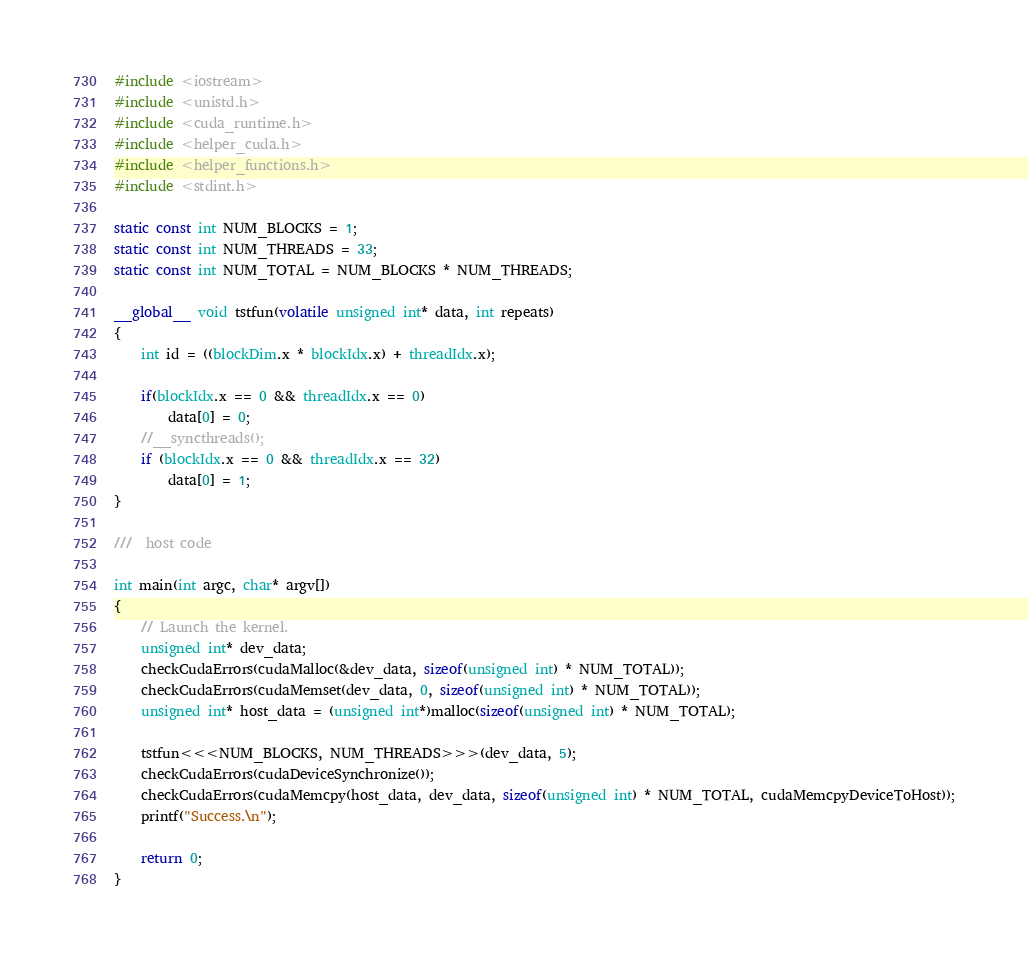<code> <loc_0><loc_0><loc_500><loc_500><_Cuda_>#include <iostream>
#include <unistd.h>
#include <cuda_runtime.h>
#include <helper_cuda.h>
#include <helper_functions.h>
#include <stdint.h>

static const int NUM_BLOCKS = 1;
static const int NUM_THREADS = 33;
static const int NUM_TOTAL = NUM_BLOCKS * NUM_THREADS;

__global__ void tstfun(volatile unsigned int* data, int repeats) 
{
    int id = ((blockDim.x * blockIdx.x) + threadIdx.x);

    if(blockIdx.x == 0 && threadIdx.x == 0)
        data[0] = 0;
    //__syncthreads();
    if (blockIdx.x == 0 && threadIdx.x == 32)
        data[0] = 1;
}

///  host code
    
int main(int argc, char* argv[]) 
{
    // Launch the kernel.
    unsigned int* dev_data;
    checkCudaErrors(cudaMalloc(&dev_data, sizeof(unsigned int) * NUM_TOTAL));
    checkCudaErrors(cudaMemset(dev_data, 0, sizeof(unsigned int) * NUM_TOTAL));
    unsigned int* host_data = (unsigned int*)malloc(sizeof(unsigned int) * NUM_TOTAL);
    
    tstfun<<<NUM_BLOCKS, NUM_THREADS>>>(dev_data, 5);
    checkCudaErrors(cudaDeviceSynchronize());
    checkCudaErrors(cudaMemcpy(host_data, dev_data, sizeof(unsigned int) * NUM_TOTAL, cudaMemcpyDeviceToHost));
    printf("Success.\n");

    return 0;
}

</code> 